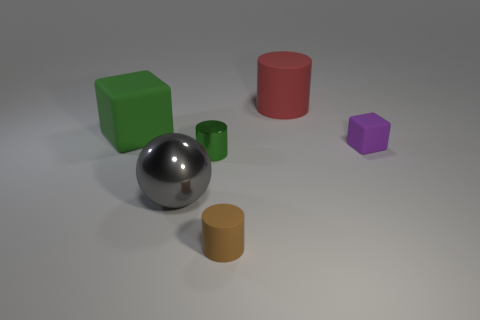Describe the lighting of the scene. Where is the light source coming from? The lighting in the image seems quite diffuse, with subtle shadows under the objects suggesting that the light source is above and possibly slightly in front of the objects, illuminating the scene fairly evenly without casting harsh shadows. 